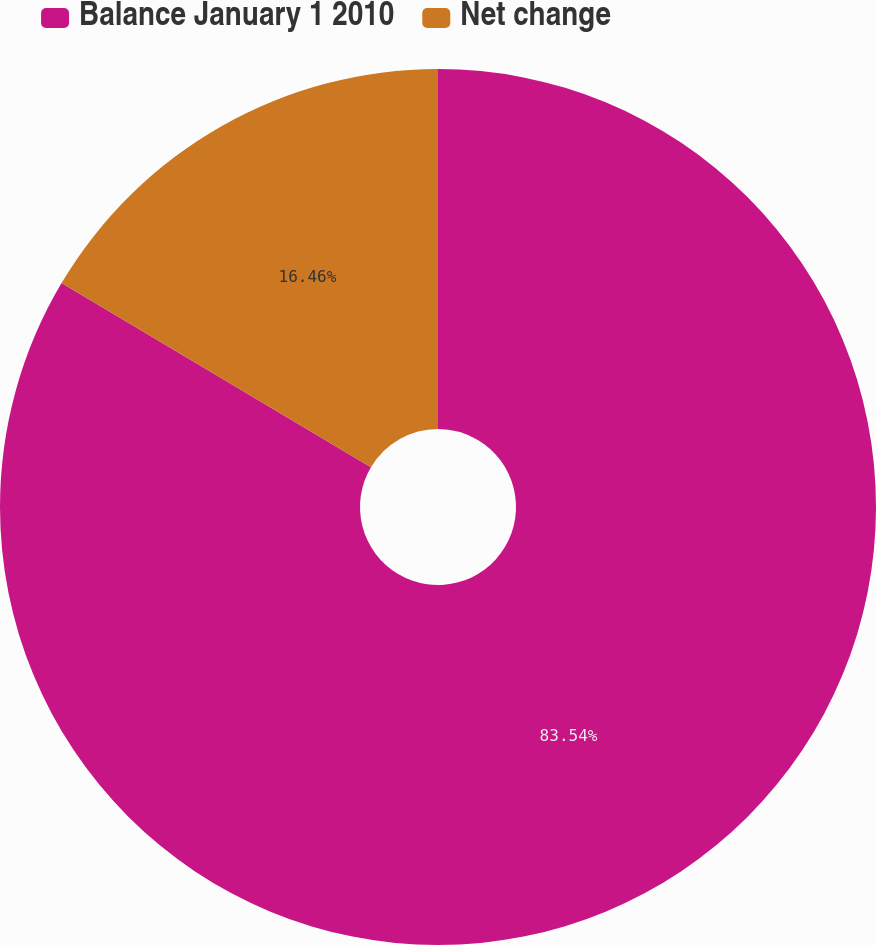<chart> <loc_0><loc_0><loc_500><loc_500><pie_chart><fcel>Balance January 1 2010<fcel>Net change<nl><fcel>83.54%<fcel>16.46%<nl></chart> 